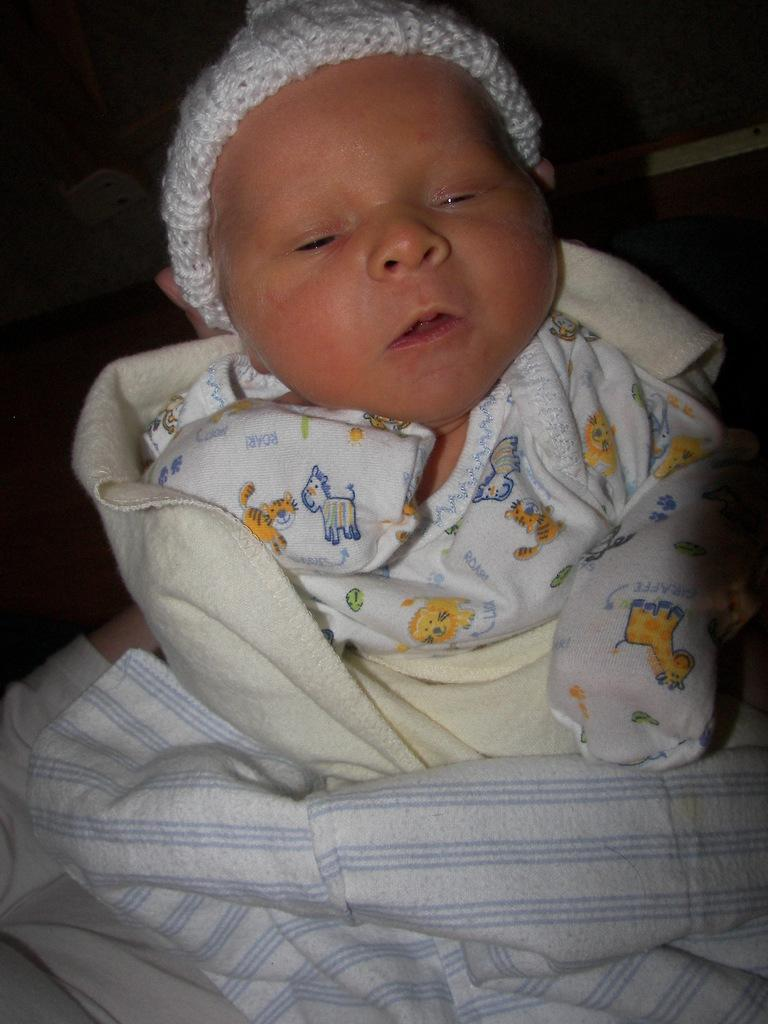What is the main subject of the image? There is a baby in the image. What color clothes is the baby wearing? The baby is wearing white and cream colored clothes. What color is the background of the image? The background of the image is black. What type of bushes can be seen in the background of the image? There are no bushes visible in the image; the background is black. What kind of invention is the baby holding in the image? There is no invention present in the image; the baby is not holding anything. 